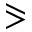Convert formula to latex. <formula><loc_0><loc_0><loc_500><loc_500>\ e q s l a n t g t r</formula> 